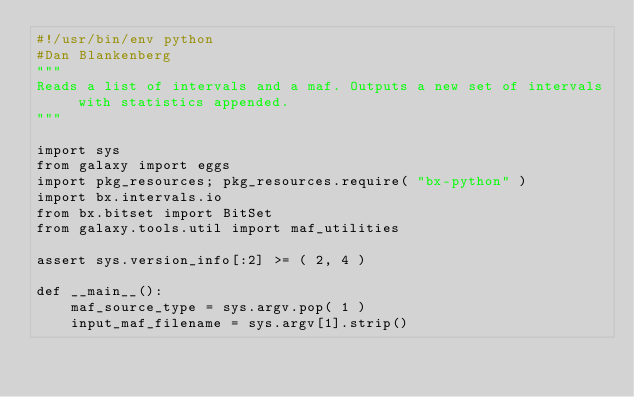<code> <loc_0><loc_0><loc_500><loc_500><_Python_>#!/usr/bin/env python
#Dan Blankenberg
"""
Reads a list of intervals and a maf. Outputs a new set of intervals with statistics appended.
"""

import sys
from galaxy import eggs
import pkg_resources; pkg_resources.require( "bx-python" )
import bx.intervals.io
from bx.bitset import BitSet
from galaxy.tools.util import maf_utilities

assert sys.version_info[:2] >= ( 2, 4 )

def __main__():
    maf_source_type = sys.argv.pop( 1 )
    input_maf_filename = sys.argv[1].strip()</code> 